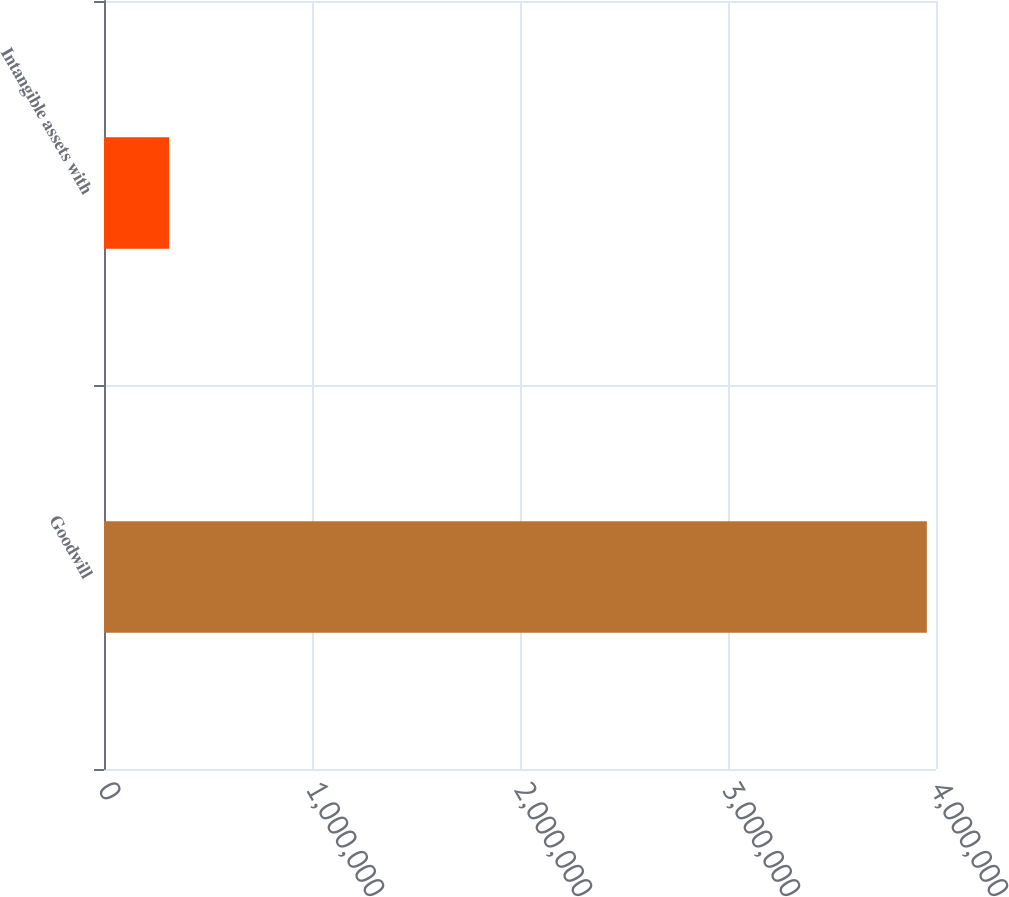<chart> <loc_0><loc_0><loc_500><loc_500><bar_chart><fcel>Goodwill<fcel>Intangible assets with<nl><fcel>3.9559e+06<fcel>313449<nl></chart> 